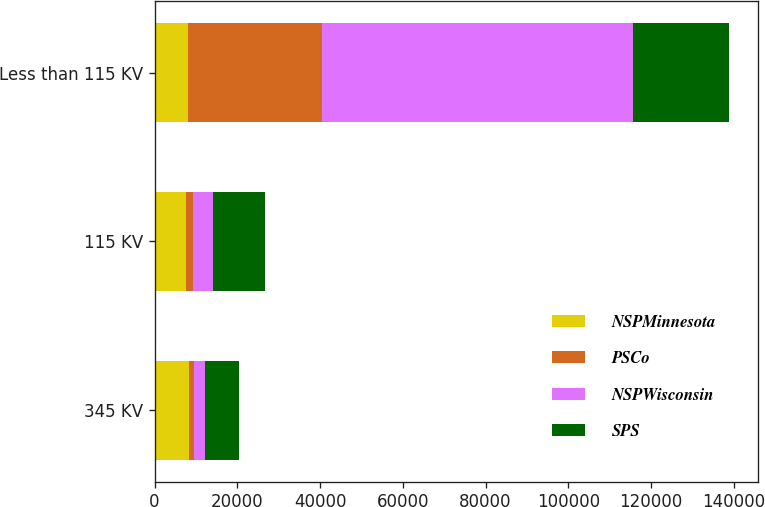Convert chart to OTSL. <chart><loc_0><loc_0><loc_500><loc_500><stacked_bar_chart><ecel><fcel>345 KV<fcel>115 KV<fcel>Less than 115 KV<nl><fcel>NSPMinnesota<fcel>8425<fcel>7502<fcel>8108<nl><fcel>PSCo<fcel>1152<fcel>1810<fcel>32355<nl><fcel>NSPWisconsin<fcel>2630<fcel>4925<fcel>75155<nl><fcel>SPS<fcel>8108<fcel>12427<fcel>23299<nl></chart> 